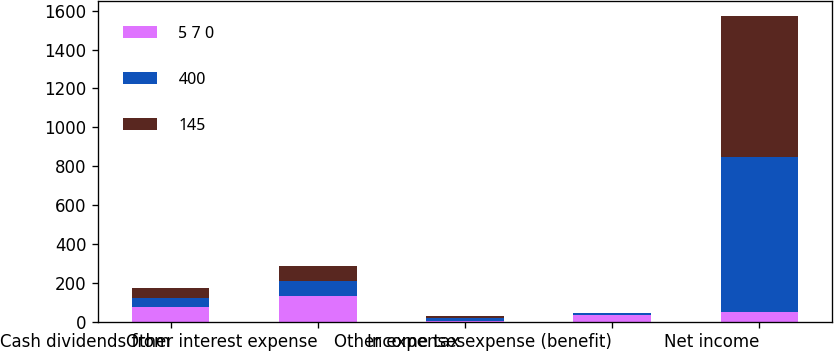Convert chart to OTSL. <chart><loc_0><loc_0><loc_500><loc_500><stacked_bar_chart><ecel><fcel>Cash dividends from<fcel>Other interest expense<fcel>Other expenses<fcel>Income tax expense (benefit)<fcel>Net income<nl><fcel>5 7 0<fcel>74<fcel>131<fcel>6<fcel>33<fcel>51<nl><fcel>400<fcel>50<fcel>78<fcel>11<fcel>11<fcel>798<nl><fcel>145<fcel>52<fcel>77<fcel>12<fcel>1<fcel>722<nl></chart> 